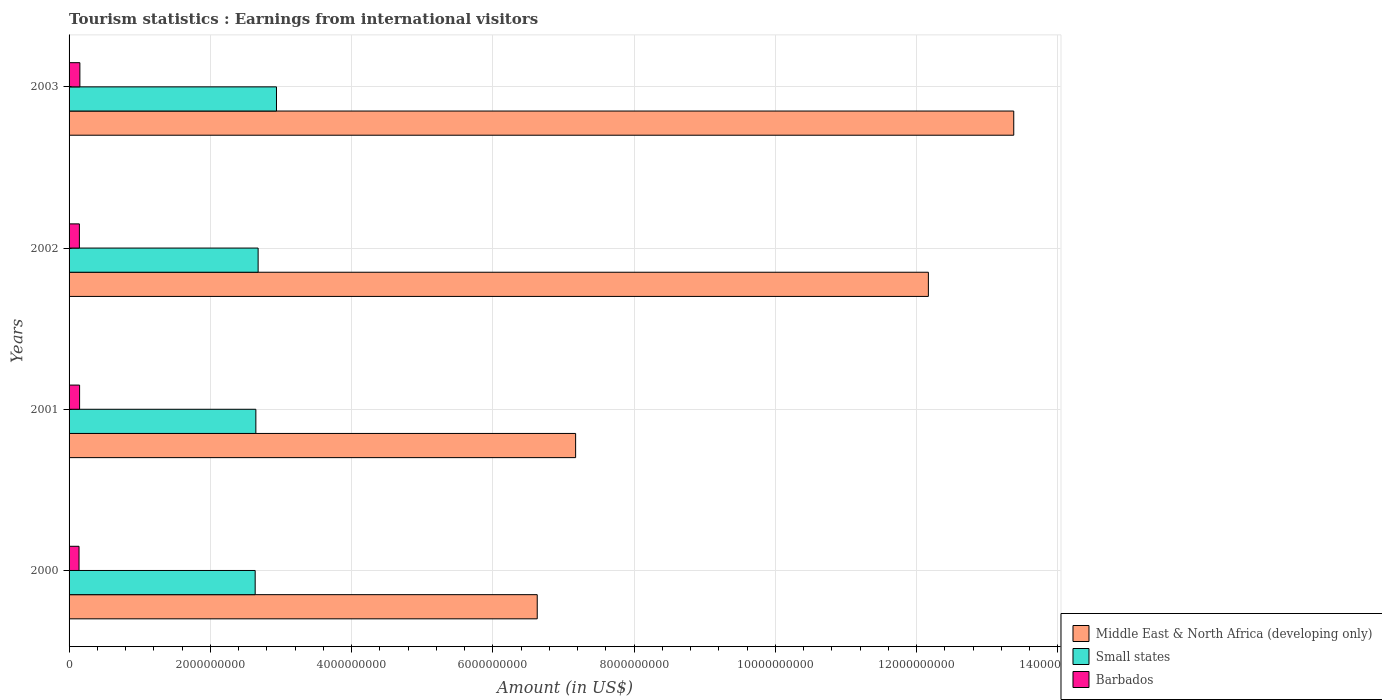How many different coloured bars are there?
Provide a short and direct response. 3. How many bars are there on the 3rd tick from the top?
Your response must be concise. 3. How many bars are there on the 4th tick from the bottom?
Give a very brief answer. 3. What is the label of the 3rd group of bars from the top?
Your answer should be very brief. 2001. In how many cases, is the number of bars for a given year not equal to the number of legend labels?
Your response must be concise. 0. What is the earnings from international visitors in Middle East & North Africa (developing only) in 2002?
Provide a succinct answer. 1.22e+1. Across all years, what is the maximum earnings from international visitors in Middle East & North Africa (developing only)?
Offer a very short reply. 1.34e+1. Across all years, what is the minimum earnings from international visitors in Middle East & North Africa (developing only)?
Your answer should be very brief. 6.63e+09. What is the total earnings from international visitors in Small states in the graph?
Ensure brevity in your answer.  1.09e+1. What is the difference between the earnings from international visitors in Small states in 2002 and that in 2003?
Keep it short and to the point. -2.60e+08. What is the difference between the earnings from international visitors in Small states in 2003 and the earnings from international visitors in Barbados in 2002?
Provide a succinct answer. 2.79e+09. What is the average earnings from international visitors in Barbados per year?
Provide a short and direct response. 1.47e+08. In the year 2003, what is the difference between the earnings from international visitors in Barbados and earnings from international visitors in Middle East & North Africa (developing only)?
Provide a succinct answer. -1.32e+1. In how many years, is the earnings from international visitors in Barbados greater than 11200000000 US$?
Your answer should be compact. 0. What is the ratio of the earnings from international visitors in Middle East & North Africa (developing only) in 2001 to that in 2003?
Offer a terse response. 0.54. What is the difference between the highest and the lowest earnings from international visitors in Small states?
Ensure brevity in your answer.  3.02e+08. In how many years, is the earnings from international visitors in Middle East & North Africa (developing only) greater than the average earnings from international visitors in Middle East & North Africa (developing only) taken over all years?
Offer a very short reply. 2. What does the 2nd bar from the top in 2001 represents?
Ensure brevity in your answer.  Small states. What does the 2nd bar from the bottom in 2003 represents?
Your response must be concise. Small states. How many bars are there?
Make the answer very short. 12. Are all the bars in the graph horizontal?
Keep it short and to the point. Yes. How many years are there in the graph?
Give a very brief answer. 4. What is the difference between two consecutive major ticks on the X-axis?
Offer a very short reply. 2.00e+09. Does the graph contain any zero values?
Give a very brief answer. No. Does the graph contain grids?
Offer a very short reply. Yes. How are the legend labels stacked?
Give a very brief answer. Vertical. What is the title of the graph?
Offer a terse response. Tourism statistics : Earnings from international visitors. What is the label or title of the Y-axis?
Offer a very short reply. Years. What is the Amount (in US$) of Middle East & North Africa (developing only) in 2000?
Provide a succinct answer. 6.63e+09. What is the Amount (in US$) in Small states in 2000?
Provide a short and direct response. 2.63e+09. What is the Amount (in US$) in Barbados in 2000?
Give a very brief answer. 1.41e+08. What is the Amount (in US$) of Middle East & North Africa (developing only) in 2001?
Keep it short and to the point. 7.17e+09. What is the Amount (in US$) of Small states in 2001?
Your answer should be compact. 2.64e+09. What is the Amount (in US$) of Barbados in 2001?
Your response must be concise. 1.49e+08. What is the Amount (in US$) in Middle East & North Africa (developing only) in 2002?
Your answer should be very brief. 1.22e+1. What is the Amount (in US$) in Small states in 2002?
Ensure brevity in your answer.  2.68e+09. What is the Amount (in US$) in Barbados in 2002?
Keep it short and to the point. 1.46e+08. What is the Amount (in US$) in Middle East & North Africa (developing only) in 2003?
Ensure brevity in your answer.  1.34e+1. What is the Amount (in US$) of Small states in 2003?
Ensure brevity in your answer.  2.94e+09. What is the Amount (in US$) in Barbados in 2003?
Your response must be concise. 1.53e+08. Across all years, what is the maximum Amount (in US$) of Middle East & North Africa (developing only)?
Your response must be concise. 1.34e+1. Across all years, what is the maximum Amount (in US$) of Small states?
Offer a terse response. 2.94e+09. Across all years, what is the maximum Amount (in US$) of Barbados?
Offer a terse response. 1.53e+08. Across all years, what is the minimum Amount (in US$) of Middle East & North Africa (developing only)?
Offer a terse response. 6.63e+09. Across all years, what is the minimum Amount (in US$) of Small states?
Keep it short and to the point. 2.63e+09. Across all years, what is the minimum Amount (in US$) in Barbados?
Your response must be concise. 1.41e+08. What is the total Amount (in US$) of Middle East & North Africa (developing only) in the graph?
Keep it short and to the point. 3.93e+1. What is the total Amount (in US$) in Small states in the graph?
Make the answer very short. 1.09e+1. What is the total Amount (in US$) of Barbados in the graph?
Keep it short and to the point. 5.89e+08. What is the difference between the Amount (in US$) in Middle East & North Africa (developing only) in 2000 and that in 2001?
Give a very brief answer. -5.44e+08. What is the difference between the Amount (in US$) in Small states in 2000 and that in 2001?
Your response must be concise. -9.66e+06. What is the difference between the Amount (in US$) of Barbados in 2000 and that in 2001?
Offer a terse response. -8.00e+06. What is the difference between the Amount (in US$) of Middle East & North Africa (developing only) in 2000 and that in 2002?
Provide a short and direct response. -5.54e+09. What is the difference between the Amount (in US$) of Small states in 2000 and that in 2002?
Your answer should be compact. -4.18e+07. What is the difference between the Amount (in US$) in Barbados in 2000 and that in 2002?
Your answer should be compact. -5.00e+06. What is the difference between the Amount (in US$) of Middle East & North Africa (developing only) in 2000 and that in 2003?
Your response must be concise. -6.75e+09. What is the difference between the Amount (in US$) of Small states in 2000 and that in 2003?
Your answer should be compact. -3.02e+08. What is the difference between the Amount (in US$) of Barbados in 2000 and that in 2003?
Give a very brief answer. -1.20e+07. What is the difference between the Amount (in US$) in Middle East & North Africa (developing only) in 2001 and that in 2002?
Provide a succinct answer. -4.99e+09. What is the difference between the Amount (in US$) of Small states in 2001 and that in 2002?
Provide a succinct answer. -3.22e+07. What is the difference between the Amount (in US$) in Barbados in 2001 and that in 2002?
Ensure brevity in your answer.  3.00e+06. What is the difference between the Amount (in US$) of Middle East & North Africa (developing only) in 2001 and that in 2003?
Make the answer very short. -6.20e+09. What is the difference between the Amount (in US$) of Small states in 2001 and that in 2003?
Your response must be concise. -2.92e+08. What is the difference between the Amount (in US$) in Barbados in 2001 and that in 2003?
Provide a short and direct response. -4.00e+06. What is the difference between the Amount (in US$) of Middle East & North Africa (developing only) in 2002 and that in 2003?
Your response must be concise. -1.21e+09. What is the difference between the Amount (in US$) of Small states in 2002 and that in 2003?
Make the answer very short. -2.60e+08. What is the difference between the Amount (in US$) of Barbados in 2002 and that in 2003?
Your answer should be very brief. -7.00e+06. What is the difference between the Amount (in US$) in Middle East & North Africa (developing only) in 2000 and the Amount (in US$) in Small states in 2001?
Offer a very short reply. 3.98e+09. What is the difference between the Amount (in US$) of Middle East & North Africa (developing only) in 2000 and the Amount (in US$) of Barbados in 2001?
Your answer should be very brief. 6.48e+09. What is the difference between the Amount (in US$) of Small states in 2000 and the Amount (in US$) of Barbados in 2001?
Provide a succinct answer. 2.49e+09. What is the difference between the Amount (in US$) in Middle East & North Africa (developing only) in 2000 and the Amount (in US$) in Small states in 2002?
Offer a very short reply. 3.95e+09. What is the difference between the Amount (in US$) in Middle East & North Africa (developing only) in 2000 and the Amount (in US$) in Barbados in 2002?
Provide a succinct answer. 6.48e+09. What is the difference between the Amount (in US$) in Small states in 2000 and the Amount (in US$) in Barbados in 2002?
Provide a short and direct response. 2.49e+09. What is the difference between the Amount (in US$) of Middle East & North Africa (developing only) in 2000 and the Amount (in US$) of Small states in 2003?
Provide a short and direct response. 3.69e+09. What is the difference between the Amount (in US$) of Middle East & North Africa (developing only) in 2000 and the Amount (in US$) of Barbados in 2003?
Make the answer very short. 6.48e+09. What is the difference between the Amount (in US$) in Small states in 2000 and the Amount (in US$) in Barbados in 2003?
Your answer should be compact. 2.48e+09. What is the difference between the Amount (in US$) in Middle East & North Africa (developing only) in 2001 and the Amount (in US$) in Small states in 2002?
Ensure brevity in your answer.  4.50e+09. What is the difference between the Amount (in US$) in Middle East & North Africa (developing only) in 2001 and the Amount (in US$) in Barbados in 2002?
Your response must be concise. 7.03e+09. What is the difference between the Amount (in US$) in Small states in 2001 and the Amount (in US$) in Barbados in 2002?
Offer a terse response. 2.50e+09. What is the difference between the Amount (in US$) of Middle East & North Africa (developing only) in 2001 and the Amount (in US$) of Small states in 2003?
Your answer should be compact. 4.24e+09. What is the difference between the Amount (in US$) of Middle East & North Africa (developing only) in 2001 and the Amount (in US$) of Barbados in 2003?
Your answer should be very brief. 7.02e+09. What is the difference between the Amount (in US$) in Small states in 2001 and the Amount (in US$) in Barbados in 2003?
Provide a succinct answer. 2.49e+09. What is the difference between the Amount (in US$) in Middle East & North Africa (developing only) in 2002 and the Amount (in US$) in Small states in 2003?
Keep it short and to the point. 9.23e+09. What is the difference between the Amount (in US$) in Middle East & North Africa (developing only) in 2002 and the Amount (in US$) in Barbados in 2003?
Ensure brevity in your answer.  1.20e+1. What is the difference between the Amount (in US$) of Small states in 2002 and the Amount (in US$) of Barbados in 2003?
Your answer should be compact. 2.52e+09. What is the average Amount (in US$) in Middle East & North Africa (developing only) per year?
Your answer should be very brief. 9.84e+09. What is the average Amount (in US$) of Small states per year?
Make the answer very short. 2.72e+09. What is the average Amount (in US$) in Barbados per year?
Your answer should be very brief. 1.47e+08. In the year 2000, what is the difference between the Amount (in US$) in Middle East & North Africa (developing only) and Amount (in US$) in Small states?
Make the answer very short. 3.99e+09. In the year 2000, what is the difference between the Amount (in US$) of Middle East & North Africa (developing only) and Amount (in US$) of Barbados?
Ensure brevity in your answer.  6.49e+09. In the year 2000, what is the difference between the Amount (in US$) of Small states and Amount (in US$) of Barbados?
Your answer should be compact. 2.49e+09. In the year 2001, what is the difference between the Amount (in US$) of Middle East & North Africa (developing only) and Amount (in US$) of Small states?
Your answer should be very brief. 4.53e+09. In the year 2001, what is the difference between the Amount (in US$) of Middle East & North Africa (developing only) and Amount (in US$) of Barbados?
Make the answer very short. 7.02e+09. In the year 2001, what is the difference between the Amount (in US$) of Small states and Amount (in US$) of Barbados?
Your answer should be very brief. 2.50e+09. In the year 2002, what is the difference between the Amount (in US$) of Middle East & North Africa (developing only) and Amount (in US$) of Small states?
Offer a very short reply. 9.49e+09. In the year 2002, what is the difference between the Amount (in US$) in Middle East & North Africa (developing only) and Amount (in US$) in Barbados?
Ensure brevity in your answer.  1.20e+1. In the year 2002, what is the difference between the Amount (in US$) of Small states and Amount (in US$) of Barbados?
Provide a succinct answer. 2.53e+09. In the year 2003, what is the difference between the Amount (in US$) in Middle East & North Africa (developing only) and Amount (in US$) in Small states?
Your answer should be compact. 1.04e+1. In the year 2003, what is the difference between the Amount (in US$) in Middle East & North Africa (developing only) and Amount (in US$) in Barbados?
Keep it short and to the point. 1.32e+1. In the year 2003, what is the difference between the Amount (in US$) in Small states and Amount (in US$) in Barbados?
Ensure brevity in your answer.  2.78e+09. What is the ratio of the Amount (in US$) in Middle East & North Africa (developing only) in 2000 to that in 2001?
Ensure brevity in your answer.  0.92. What is the ratio of the Amount (in US$) of Barbados in 2000 to that in 2001?
Ensure brevity in your answer.  0.95. What is the ratio of the Amount (in US$) of Middle East & North Africa (developing only) in 2000 to that in 2002?
Your answer should be very brief. 0.54. What is the ratio of the Amount (in US$) of Small states in 2000 to that in 2002?
Provide a short and direct response. 0.98. What is the ratio of the Amount (in US$) of Barbados in 2000 to that in 2002?
Your response must be concise. 0.97. What is the ratio of the Amount (in US$) in Middle East & North Africa (developing only) in 2000 to that in 2003?
Offer a terse response. 0.5. What is the ratio of the Amount (in US$) of Small states in 2000 to that in 2003?
Keep it short and to the point. 0.9. What is the ratio of the Amount (in US$) of Barbados in 2000 to that in 2003?
Your response must be concise. 0.92. What is the ratio of the Amount (in US$) in Middle East & North Africa (developing only) in 2001 to that in 2002?
Your response must be concise. 0.59. What is the ratio of the Amount (in US$) in Barbados in 2001 to that in 2002?
Your response must be concise. 1.02. What is the ratio of the Amount (in US$) in Middle East & North Africa (developing only) in 2001 to that in 2003?
Offer a very short reply. 0.54. What is the ratio of the Amount (in US$) in Small states in 2001 to that in 2003?
Provide a short and direct response. 0.9. What is the ratio of the Amount (in US$) in Barbados in 2001 to that in 2003?
Your answer should be very brief. 0.97. What is the ratio of the Amount (in US$) in Middle East & North Africa (developing only) in 2002 to that in 2003?
Give a very brief answer. 0.91. What is the ratio of the Amount (in US$) in Small states in 2002 to that in 2003?
Give a very brief answer. 0.91. What is the ratio of the Amount (in US$) of Barbados in 2002 to that in 2003?
Your answer should be very brief. 0.95. What is the difference between the highest and the second highest Amount (in US$) of Middle East & North Africa (developing only)?
Keep it short and to the point. 1.21e+09. What is the difference between the highest and the second highest Amount (in US$) of Small states?
Keep it short and to the point. 2.60e+08. What is the difference between the highest and the second highest Amount (in US$) in Barbados?
Give a very brief answer. 4.00e+06. What is the difference between the highest and the lowest Amount (in US$) in Middle East & North Africa (developing only)?
Give a very brief answer. 6.75e+09. What is the difference between the highest and the lowest Amount (in US$) in Small states?
Make the answer very short. 3.02e+08. 